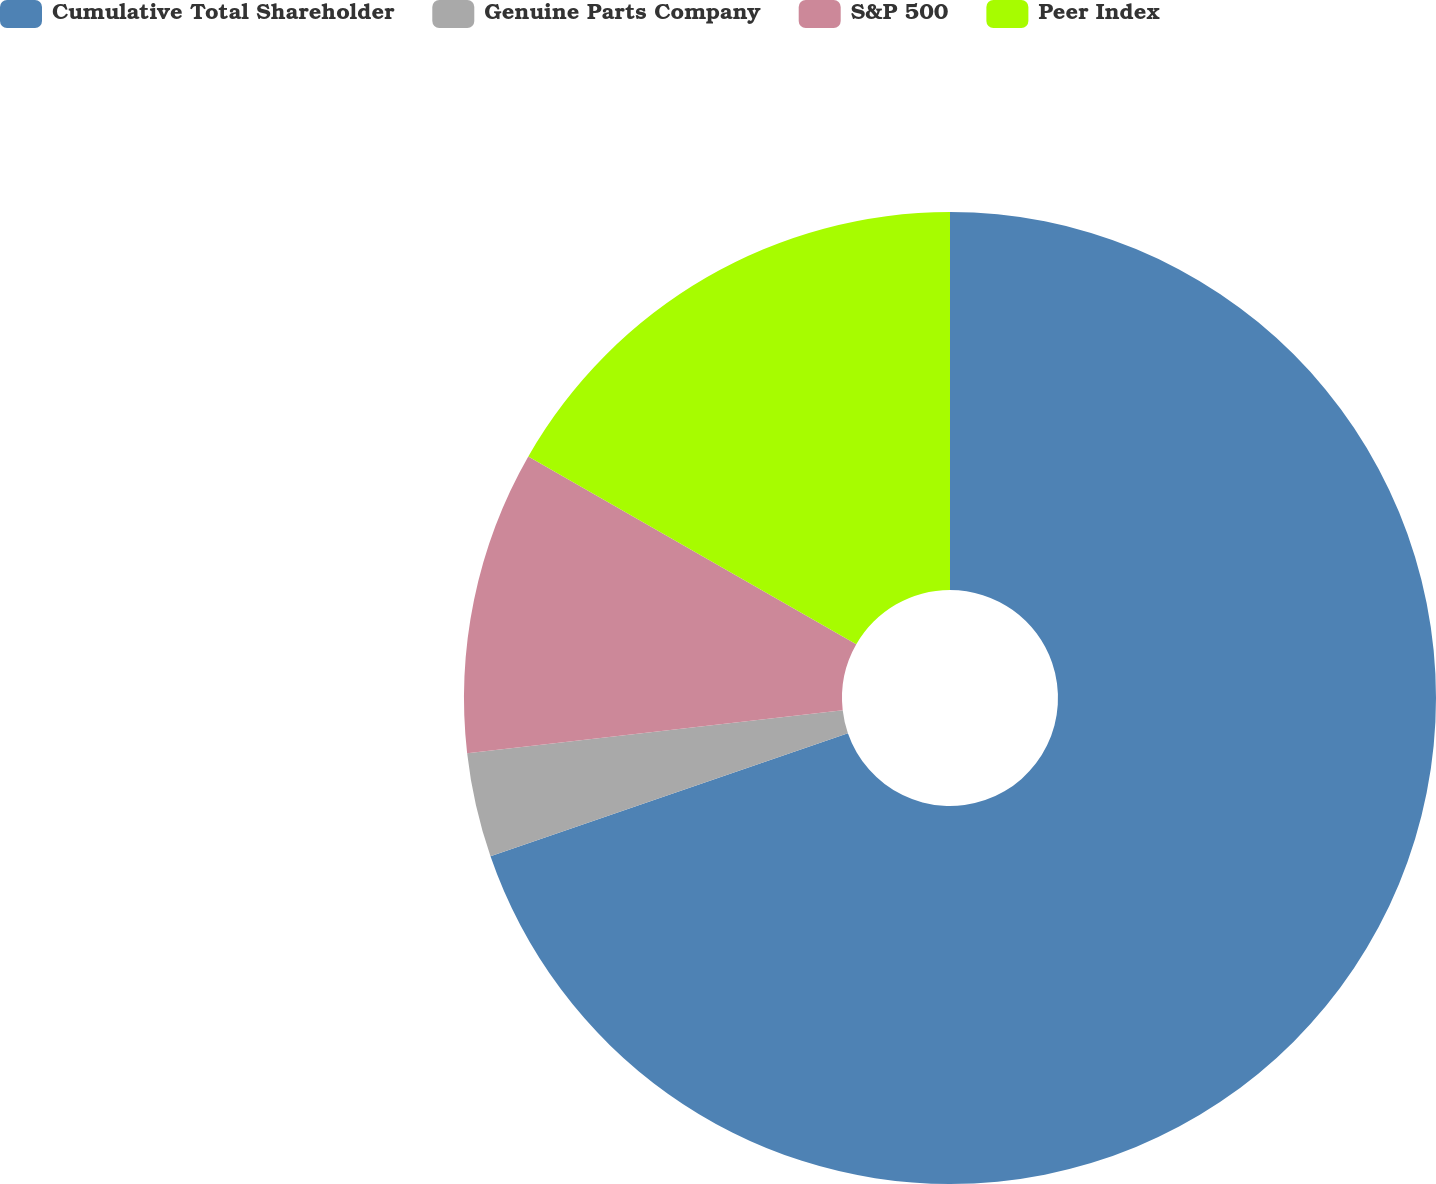Convert chart to OTSL. <chart><loc_0><loc_0><loc_500><loc_500><pie_chart><fcel>Cumulative Total Shareholder<fcel>Genuine Parts Company<fcel>S&P 500<fcel>Peer Index<nl><fcel>69.72%<fcel>3.47%<fcel>10.09%<fcel>16.72%<nl></chart> 